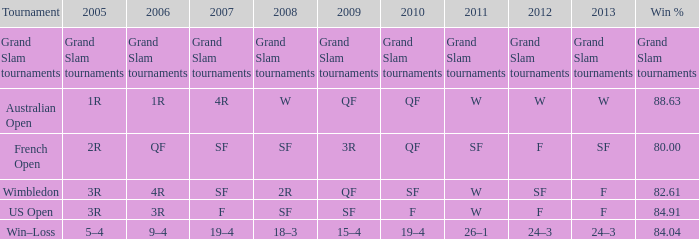What in 2007 has a 2010 of qf, and a 2012 of w? 4R. Can you give me this table as a dict? {'header': ['Tournament', '2005', '2006', '2007', '2008', '2009', '2010', '2011', '2012', '2013', 'Win %'], 'rows': [['Grand Slam tournaments', 'Grand Slam tournaments', 'Grand Slam tournaments', 'Grand Slam tournaments', 'Grand Slam tournaments', 'Grand Slam tournaments', 'Grand Slam tournaments', 'Grand Slam tournaments', 'Grand Slam tournaments', 'Grand Slam tournaments', 'Grand Slam tournaments'], ['Australian Open', '1R', '1R', '4R', 'W', 'QF', 'QF', 'W', 'W', 'W', '88.63'], ['French Open', '2R', 'QF', 'SF', 'SF', '3R', 'QF', 'SF', 'F', 'SF', '80.00'], ['Wimbledon', '3R', '4R', 'SF', '2R', 'QF', 'SF', 'W', 'SF', 'F', '82.61'], ['US Open', '3R', '3R', 'F', 'SF', 'SF', 'F', 'W', 'F', 'F', '84.91'], ['Win–Loss', '5–4', '9–4', '19–4', '18–3', '15–4', '19–4', '26–1', '24–3', '24–3', '84.04']]} 